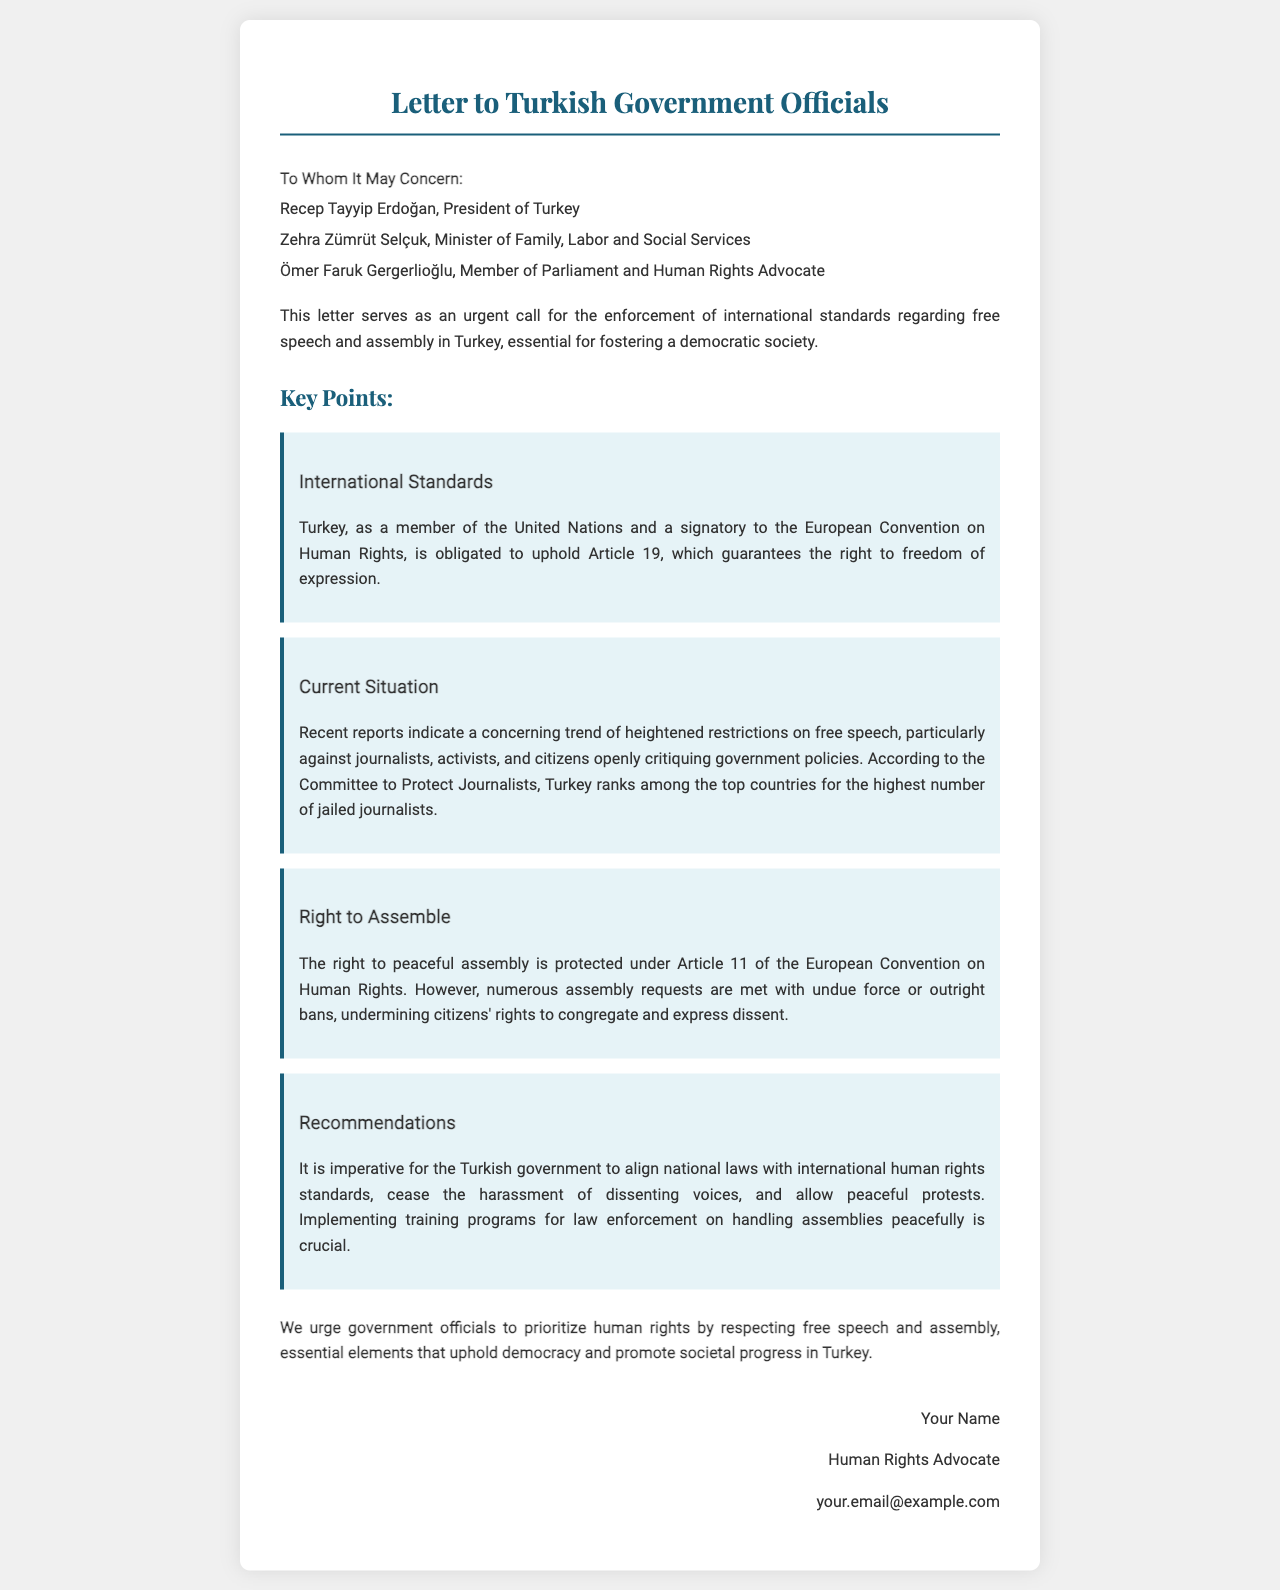What is the title of the letter? The title of the letter is stated at the top of the document.
Answer: Letter to Turkish Government Officials Who is the President of Turkey mentioned in the letter? The letter lists the current President of Turkey among the recipients.
Answer: Recep Tayyip Erdoğan What article of the European Convention on Human Rights guarantees the right to freedom of expression? This information is provided in the key point regarding international standards in the letter.
Answer: Article 19 What organization ranks Turkey among the top countries for jailed journalists? The letter references this organization when discussing the current situation of free speech in Turkey.
Answer: Committee to Protect Journalists What is the key recommendation for improving the situation regarding assemblies? This recommendation is outlined in the key points section of the letter.
Answer: Training programs for law enforcement What right is protected under Article 11 of the European Convention on Human Rights? This right is highlighted in the key point about the right to assemble in the letter.
Answer: The right to peaceful assembly What is the conclusion urging government officials to prioritize? The conclusion summarizes the essential elements for societal progress mentioned in the letter.
Answer: Human rights How many individuals are addressed in the recipient section of the letter? The number of individuals is listed in the recipient section.
Answer: Three 